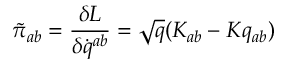<formula> <loc_0><loc_0><loc_500><loc_500>\tilde { \pi } _ { a b } = { \frac { \delta L } { \delta \dot { q } ^ { a b } } } = \sqrt { q } ( K _ { a b } - K q _ { a b } )</formula> 